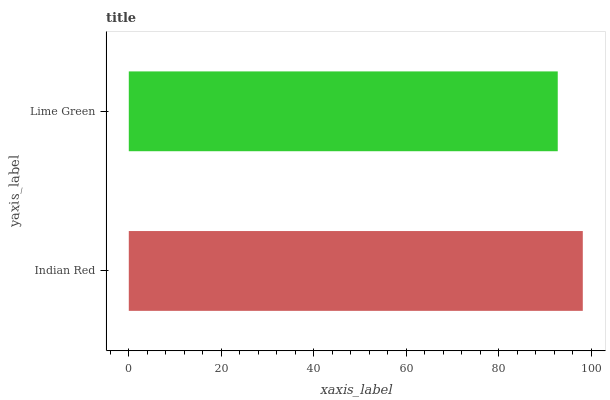Is Lime Green the minimum?
Answer yes or no. Yes. Is Indian Red the maximum?
Answer yes or no. Yes. Is Lime Green the maximum?
Answer yes or no. No. Is Indian Red greater than Lime Green?
Answer yes or no. Yes. Is Lime Green less than Indian Red?
Answer yes or no. Yes. Is Lime Green greater than Indian Red?
Answer yes or no. No. Is Indian Red less than Lime Green?
Answer yes or no. No. Is Indian Red the high median?
Answer yes or no. Yes. Is Lime Green the low median?
Answer yes or no. Yes. Is Lime Green the high median?
Answer yes or no. No. Is Indian Red the low median?
Answer yes or no. No. 